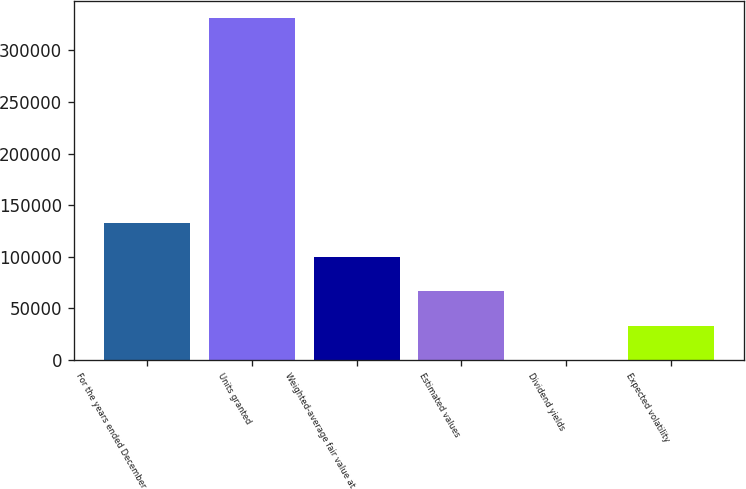Convert chart to OTSL. <chart><loc_0><loc_0><loc_500><loc_500><bar_chart><fcel>For the years ended December<fcel>Units granted<fcel>Weighted-average fair value at<fcel>Estimated values<fcel>Dividend yields<fcel>Expected volatility<nl><fcel>132716<fcel>331788<fcel>99537.7<fcel>66359<fcel>1.8<fcel>33180.4<nl></chart> 